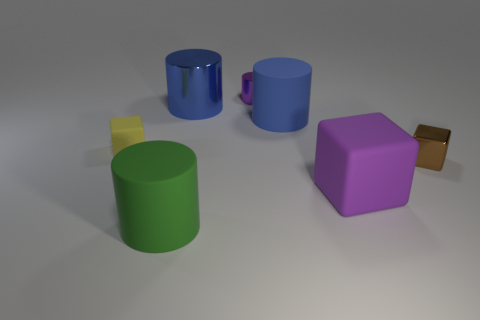Subtract all blue cylinders. How many were subtracted if there are1blue cylinders left? 1 Add 2 purple cylinders. How many objects exist? 9 Subtract all big rubber cubes. How many cubes are left? 2 Subtract all cubes. How many objects are left? 4 Subtract 2 cylinders. How many cylinders are left? 2 Subtract all gray cylinders. Subtract all blue blocks. How many cylinders are left? 4 Subtract all yellow balls. How many brown cylinders are left? 0 Subtract all metal things. Subtract all big brown rubber objects. How many objects are left? 4 Add 3 green cylinders. How many green cylinders are left? 4 Add 3 brown objects. How many brown objects exist? 4 